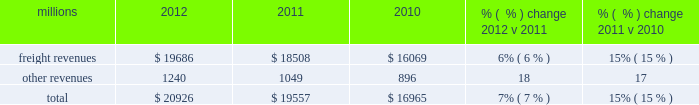F0b7 positive train control 2013 in response to a legislative mandate to implement ptc , we expect to spend approximately $ 450 million during 2013 on developing and deploying ptc .
We currently estimate that ptc , in accordance with implementing rules issued by the federal rail administration ( fra ) , will cost us approximately $ 2 billion by the end of the project .
This includes costs for installing the new system along our tracks , upgrading locomotives to work with the new system , and adding digital data communication equipment to integrate the components of the system .
F0b7 financial expectations 2013 we are cautious about the economic environment but if industrial production grows approximately 2% ( 2 % ) as projected , volume should exceed 2012 levels .
Even with no volume growth , we expect earnings to exceed 2012 earnings , generated by real core pricing gains , on-going network improvements and operational productivity initiatives .
We also expect that a new bonus depreciation program under federal tax laws will positively impact cash flows in 2013 .
Results of operations operating revenues millions 2012 2011 2010 % (  % ) change 2012 v 2011 % (  % ) change 2011 v 2010 .
We generate freight revenues by transporting freight or other materials from our six commodity groups .
Freight revenues vary with volume ( carloads ) and average revenue per car ( arc ) .
Changes in price , traffic mix and fuel surcharges drive arc .
We provide some of our customers with contractual incentives for meeting or exceeding specified cumulative volumes or shipping to and from specific locations , which we record as reductions to freight revenues based on the actual or projected future shipments .
We recognize freight revenues as shipments move from origin to destination .
We allocate freight revenues between reporting periods based on the relative transit time in each reporting period and recognize expenses as we incur them .
Other revenues include revenues earned by our subsidiaries , revenues from our commuter rail operations , and accessorial revenues , which we earn when customers retain equipment owned or controlled by us or when we perform additional services such as switching or storage .
We recognize other revenues as we perform services or meet contractual obligations .
Freight revenues from four of our six commodity groups increased during 2012 compared to 2011 .
Revenues from coal and agricultural products declined during the year .
Our franchise diversity allowed us to take advantage of growth from shale-related markets ( crude oil , frac sand and pipe ) and strong automotive manufacturing , which offset volume declines from coal and agricultural products .
Arc increased 7% ( 7 % ) , driven by core pricing gains and higher fuel cost recoveries .
Improved fuel recovery provisions and higher fuel prices , including the lag effect of our programs ( surcharges trail fluctuations in fuel price by approximately two months ) , combined to increase revenues from fuel surcharges .
Freight revenues for all six commodity groups increased during 2011 compared to 2010 , while volume increased in all commodity groups except intermodal .
Increased demand in many market sectors , with particularly strong growth in chemicals , industrial products , and automotive shipments for the year , generated the increases .
Arc increased 12% ( 12 % ) , driven by higher fuel cost recoveries and core pricing gains .
Fuel cost recoveries include fuel surcharge revenue and the impact of resetting the base fuel price for certain traffic .
Higher fuel prices , volume growth , and new fuel surcharge provisions in renegotiated contracts all combined to increase revenues from fuel surcharges .
Our fuel surcharge programs ( excluding index-based contract escalators that contain some provision for fuel ) generated freight revenues of $ 2.6 billion , $ 2.2 billion , and $ 1.2 billion in 2012 , 2011 , and 2010 , respectively .
Ongoing rising fuel prices and increased fuel surcharge coverage drove the increases .
Additionally , fuel surcharge revenue is not entirely comparable to prior periods as we continue to convert portions of our non-regulated traffic to mileage-based fuel surcharge programs. .
If freight revenues increase at the same rate as 2012 , what would expected 2013 revenues be , in millions? 
Computations: (19686 + 6%)
Answer: 19686.06. 